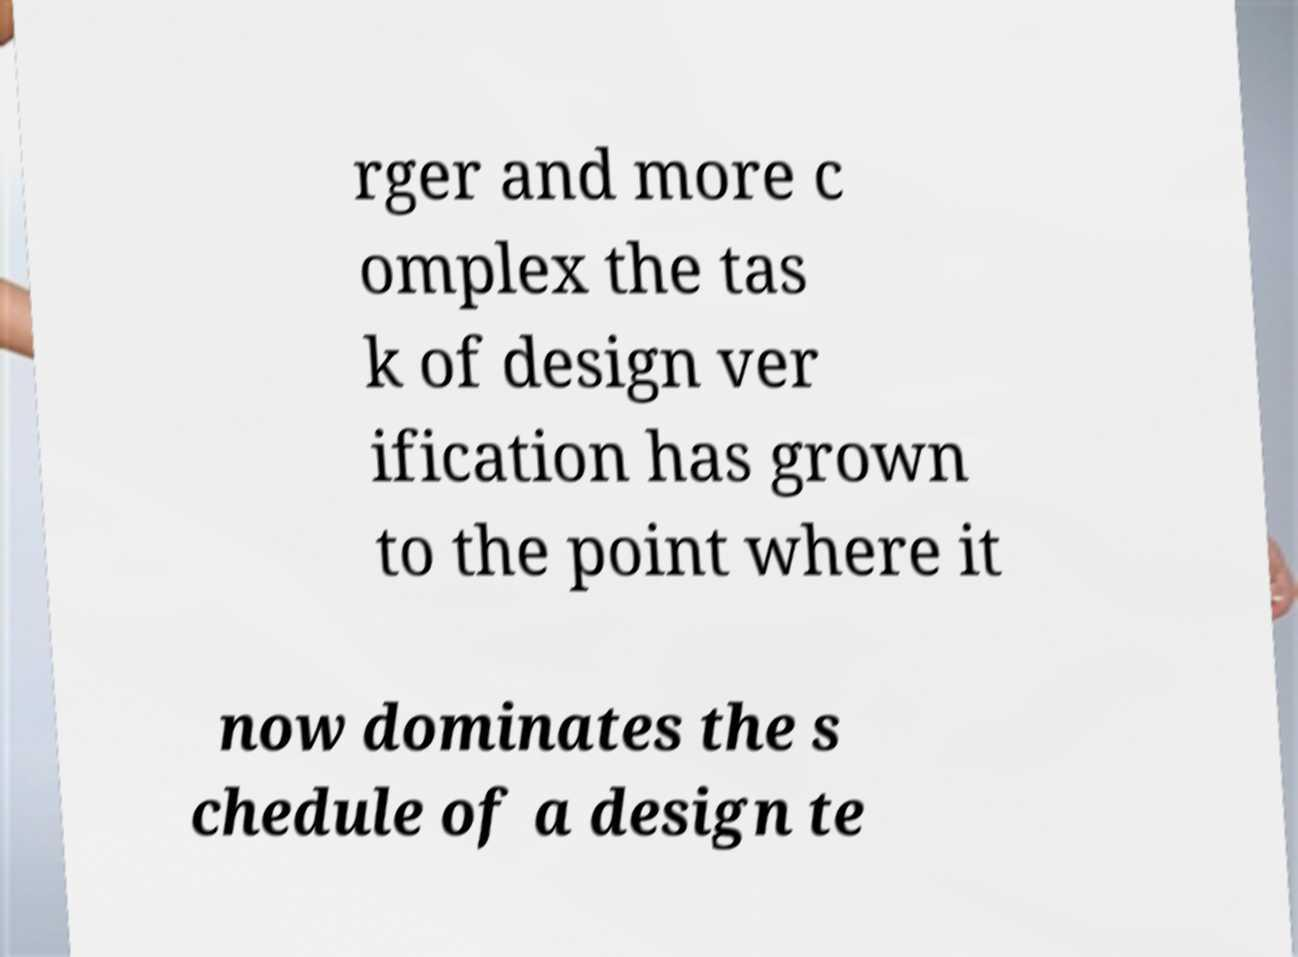Can you read and provide the text displayed in the image?This photo seems to have some interesting text. Can you extract and type it out for me? rger and more c omplex the tas k of design ver ification has grown to the point where it now dominates the s chedule of a design te 